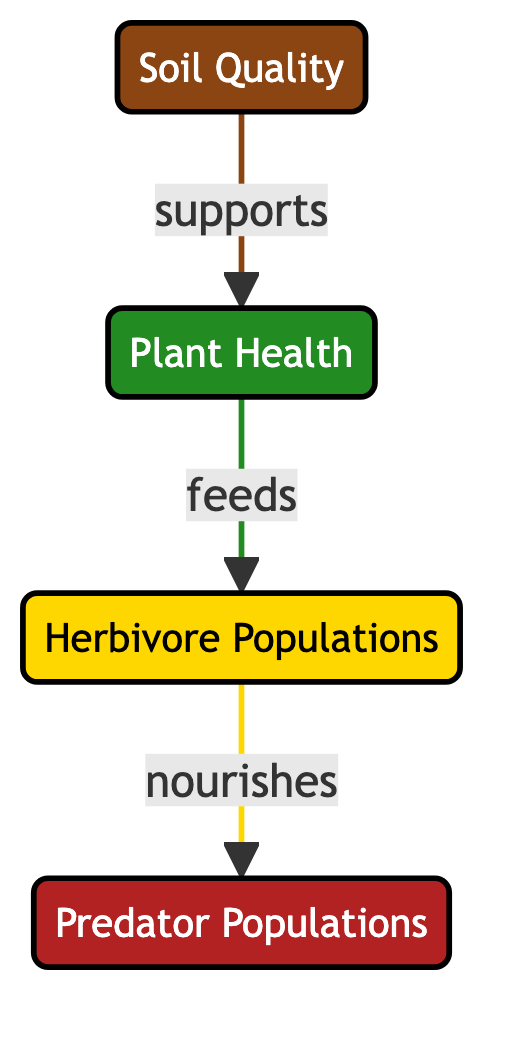What are the nodes present in this food chain? The food chain has four nodes: Soil Quality, Plant Health, Herbivore Populations, and Predator Populations.
Answer: Soil Quality, Plant Health, Herbivore Populations, Predator Populations What supports Plant Health? The diagram shows an arrow leading directly from Soil Quality to Plant Health, indicating that Soil Quality supports Plant Health.
Answer: Soil Quality Which population is primarily fed by Plant Health? The arrow from Plant Health to Herbivore Populations signifies that Herbivores are primarily fed by Plant Health.
Answer: Herbivore Populations How many arrows are in this diagram? There are three arrows indicating the relationships between the nodes: Soil to Plant Health, Plant Health to Herbivores, and Herbivores to Predators.
Answer: Three If Soil Quality decreases, what is the potential impact on Predator Populations? A decrease in Soil Quality is likely to lead to reduced Plant Health, which would in turn decrease the number of Herbivores that can be supported, eventually resulting in a decline in Predator Populations.
Answer: Decrease What does the arrow from Herbivores nourish? The diagram shows that Herbivores nourish Predator Populations, as indicated by the arrow pointing from Herbivores to Predators.
Answer: Predator Populations What is the relationship between Soil Quality and Predator Populations? Soil Quality influences Plant Health, which affects Herbivore populations, and subsequently the Herbivores nourish Predator Populations, creating an indirect relationship between Soil Quality and Predator Populations.
Answer: Indirect What type of diagram is being represented here? The diagram illustrates a food chain, specifically relating to the impact of agricultural practices on various ecological components.
Answer: Food chain 